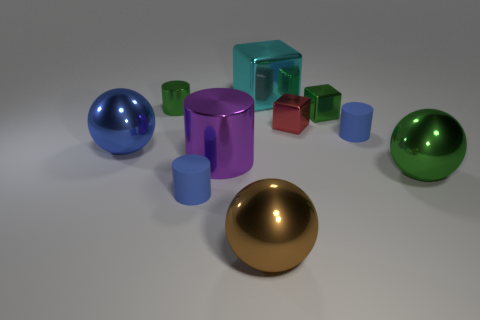Subtract all brown balls. Subtract all blue blocks. How many balls are left? 2 Subtract all balls. How many objects are left? 7 Add 5 large blue metallic spheres. How many large blue metallic spheres are left? 6 Add 1 large gray metal things. How many large gray metal things exist? 1 Subtract 0 gray cubes. How many objects are left? 10 Subtract all large shiny cylinders. Subtract all tiny cyan shiny cylinders. How many objects are left? 9 